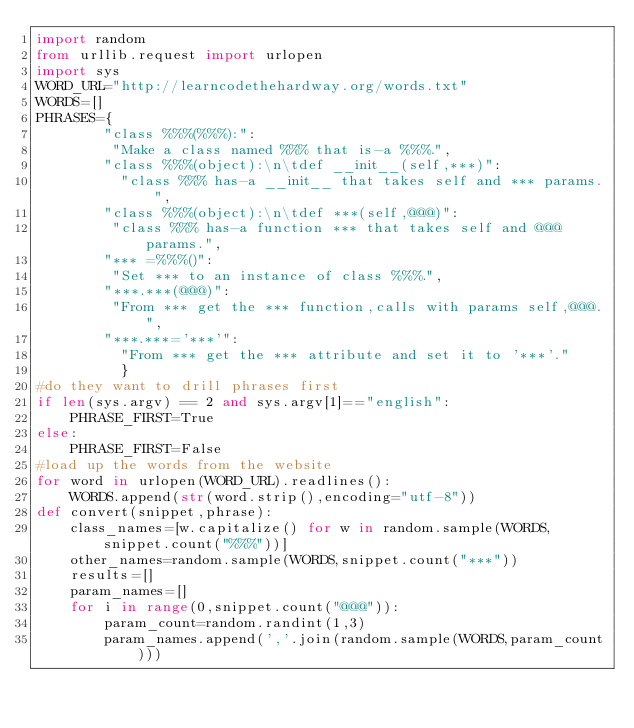<code> <loc_0><loc_0><loc_500><loc_500><_Python_>import random
from urllib.request import urlopen
import sys
WORD_URL="http://learncodethehardway.org/words.txt"
WORDS=[]
PHRASES={
        "class %%%(%%%):":
         "Make a class named %%% that is-a %%%.",
        "class %%%(object):\n\tdef __init__(self,***)":
          "class %%% has-a __init__ that takes self and *** params.",
        "class %%%(object):\n\tdef ***(self,@@@)":
         "class %%% has-a function *** that takes self and @@@ params.",
        "*** =%%%()":
         "Set *** to an instance of class %%%.",
        "***.***(@@@)":
         "From *** get the *** function,calls with params self,@@@.",
        "***.***='***'":
          "From *** get the *** attribute and set it to '***'."
          }
#do they want to drill phrases first
if len(sys.argv) == 2 and sys.argv[1]=="english":
    PHRASE_FIRST=True 
else:
    PHRASE_FIRST=False
#load up the words from the website
for word in urlopen(WORD_URL).readlines():
    WORDS.append(str(word.strip(),encoding="utf-8"))
def convert(snippet,phrase):
    class_names=[w.capitalize() for w in random.sample(WORDS,snippet.count("%%%"))]
    other_names=random.sample(WORDS,snippet.count("***"))
    results=[]
    param_names=[]
    for i in range(0,snippet.count("@@@")):
        param_count=random.randint(1,3)
        param_names.append(','.join(random.sample(WORDS,param_count)))</code> 